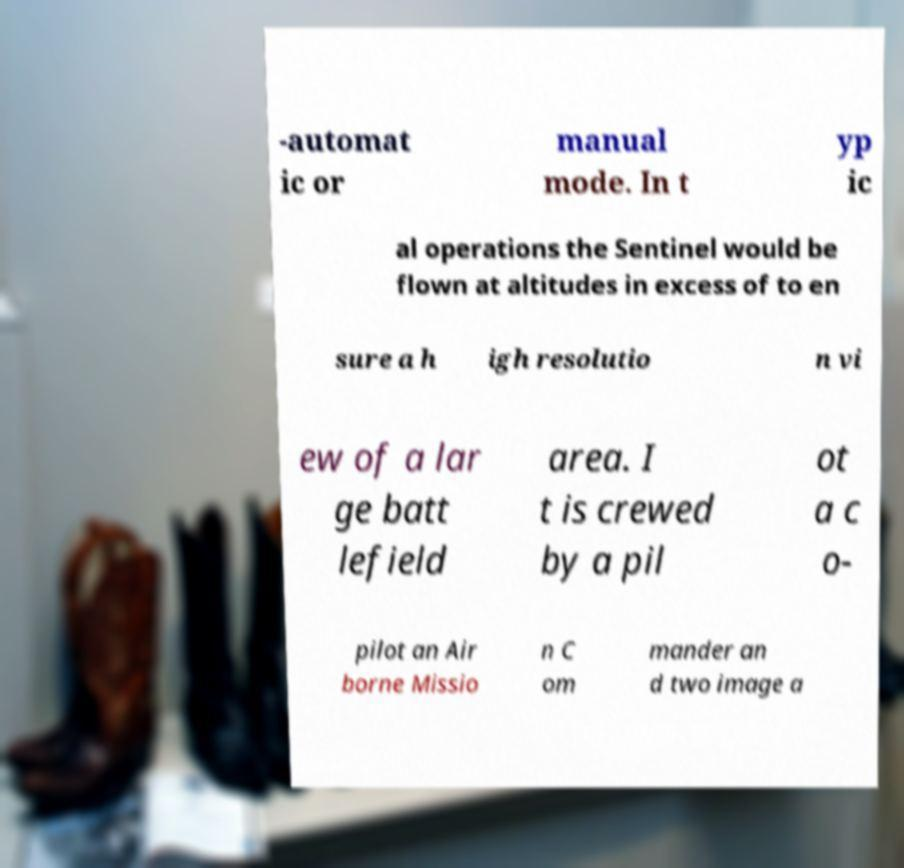For documentation purposes, I need the text within this image transcribed. Could you provide that? -automat ic or manual mode. In t yp ic al operations the Sentinel would be flown at altitudes in excess of to en sure a h igh resolutio n vi ew of a lar ge batt lefield area. I t is crewed by a pil ot a c o- pilot an Air borne Missio n C om mander an d two image a 